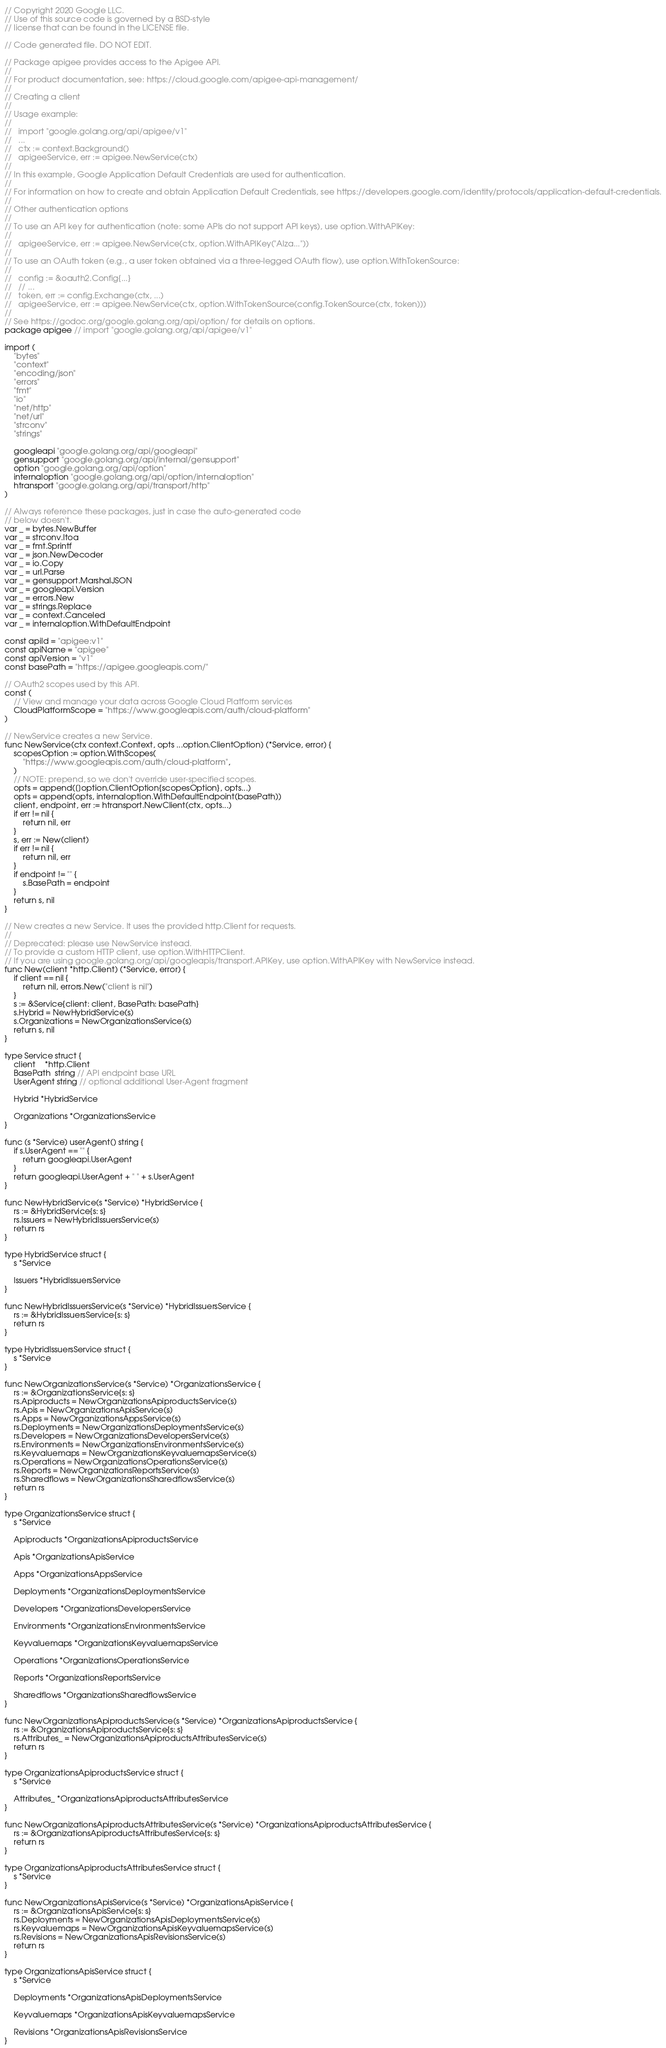<code> <loc_0><loc_0><loc_500><loc_500><_Go_>// Copyright 2020 Google LLC.
// Use of this source code is governed by a BSD-style
// license that can be found in the LICENSE file.

// Code generated file. DO NOT EDIT.

// Package apigee provides access to the Apigee API.
//
// For product documentation, see: https://cloud.google.com/apigee-api-management/
//
// Creating a client
//
// Usage example:
//
//   import "google.golang.org/api/apigee/v1"
//   ...
//   ctx := context.Background()
//   apigeeService, err := apigee.NewService(ctx)
//
// In this example, Google Application Default Credentials are used for authentication.
//
// For information on how to create and obtain Application Default Credentials, see https://developers.google.com/identity/protocols/application-default-credentials.
//
// Other authentication options
//
// To use an API key for authentication (note: some APIs do not support API keys), use option.WithAPIKey:
//
//   apigeeService, err := apigee.NewService(ctx, option.WithAPIKey("AIza..."))
//
// To use an OAuth token (e.g., a user token obtained via a three-legged OAuth flow), use option.WithTokenSource:
//
//   config := &oauth2.Config{...}
//   // ...
//   token, err := config.Exchange(ctx, ...)
//   apigeeService, err := apigee.NewService(ctx, option.WithTokenSource(config.TokenSource(ctx, token)))
//
// See https://godoc.org/google.golang.org/api/option/ for details on options.
package apigee // import "google.golang.org/api/apigee/v1"

import (
	"bytes"
	"context"
	"encoding/json"
	"errors"
	"fmt"
	"io"
	"net/http"
	"net/url"
	"strconv"
	"strings"

	googleapi "google.golang.org/api/googleapi"
	gensupport "google.golang.org/api/internal/gensupport"
	option "google.golang.org/api/option"
	internaloption "google.golang.org/api/option/internaloption"
	htransport "google.golang.org/api/transport/http"
)

// Always reference these packages, just in case the auto-generated code
// below doesn't.
var _ = bytes.NewBuffer
var _ = strconv.Itoa
var _ = fmt.Sprintf
var _ = json.NewDecoder
var _ = io.Copy
var _ = url.Parse
var _ = gensupport.MarshalJSON
var _ = googleapi.Version
var _ = errors.New
var _ = strings.Replace
var _ = context.Canceled
var _ = internaloption.WithDefaultEndpoint

const apiId = "apigee:v1"
const apiName = "apigee"
const apiVersion = "v1"
const basePath = "https://apigee.googleapis.com/"

// OAuth2 scopes used by this API.
const (
	// View and manage your data across Google Cloud Platform services
	CloudPlatformScope = "https://www.googleapis.com/auth/cloud-platform"
)

// NewService creates a new Service.
func NewService(ctx context.Context, opts ...option.ClientOption) (*Service, error) {
	scopesOption := option.WithScopes(
		"https://www.googleapis.com/auth/cloud-platform",
	)
	// NOTE: prepend, so we don't override user-specified scopes.
	opts = append([]option.ClientOption{scopesOption}, opts...)
	opts = append(opts, internaloption.WithDefaultEndpoint(basePath))
	client, endpoint, err := htransport.NewClient(ctx, opts...)
	if err != nil {
		return nil, err
	}
	s, err := New(client)
	if err != nil {
		return nil, err
	}
	if endpoint != "" {
		s.BasePath = endpoint
	}
	return s, nil
}

// New creates a new Service. It uses the provided http.Client for requests.
//
// Deprecated: please use NewService instead.
// To provide a custom HTTP client, use option.WithHTTPClient.
// If you are using google.golang.org/api/googleapis/transport.APIKey, use option.WithAPIKey with NewService instead.
func New(client *http.Client) (*Service, error) {
	if client == nil {
		return nil, errors.New("client is nil")
	}
	s := &Service{client: client, BasePath: basePath}
	s.Hybrid = NewHybridService(s)
	s.Organizations = NewOrganizationsService(s)
	return s, nil
}

type Service struct {
	client    *http.Client
	BasePath  string // API endpoint base URL
	UserAgent string // optional additional User-Agent fragment

	Hybrid *HybridService

	Organizations *OrganizationsService
}

func (s *Service) userAgent() string {
	if s.UserAgent == "" {
		return googleapi.UserAgent
	}
	return googleapi.UserAgent + " " + s.UserAgent
}

func NewHybridService(s *Service) *HybridService {
	rs := &HybridService{s: s}
	rs.Issuers = NewHybridIssuersService(s)
	return rs
}

type HybridService struct {
	s *Service

	Issuers *HybridIssuersService
}

func NewHybridIssuersService(s *Service) *HybridIssuersService {
	rs := &HybridIssuersService{s: s}
	return rs
}

type HybridIssuersService struct {
	s *Service
}

func NewOrganizationsService(s *Service) *OrganizationsService {
	rs := &OrganizationsService{s: s}
	rs.Apiproducts = NewOrganizationsApiproductsService(s)
	rs.Apis = NewOrganizationsApisService(s)
	rs.Apps = NewOrganizationsAppsService(s)
	rs.Deployments = NewOrganizationsDeploymentsService(s)
	rs.Developers = NewOrganizationsDevelopersService(s)
	rs.Environments = NewOrganizationsEnvironmentsService(s)
	rs.Keyvaluemaps = NewOrganizationsKeyvaluemapsService(s)
	rs.Operations = NewOrganizationsOperationsService(s)
	rs.Reports = NewOrganizationsReportsService(s)
	rs.Sharedflows = NewOrganizationsSharedflowsService(s)
	return rs
}

type OrganizationsService struct {
	s *Service

	Apiproducts *OrganizationsApiproductsService

	Apis *OrganizationsApisService

	Apps *OrganizationsAppsService

	Deployments *OrganizationsDeploymentsService

	Developers *OrganizationsDevelopersService

	Environments *OrganizationsEnvironmentsService

	Keyvaluemaps *OrganizationsKeyvaluemapsService

	Operations *OrganizationsOperationsService

	Reports *OrganizationsReportsService

	Sharedflows *OrganizationsSharedflowsService
}

func NewOrganizationsApiproductsService(s *Service) *OrganizationsApiproductsService {
	rs := &OrganizationsApiproductsService{s: s}
	rs.Attributes_ = NewOrganizationsApiproductsAttributesService(s)
	return rs
}

type OrganizationsApiproductsService struct {
	s *Service

	Attributes_ *OrganizationsApiproductsAttributesService
}

func NewOrganizationsApiproductsAttributesService(s *Service) *OrganizationsApiproductsAttributesService {
	rs := &OrganizationsApiproductsAttributesService{s: s}
	return rs
}

type OrganizationsApiproductsAttributesService struct {
	s *Service
}

func NewOrganizationsApisService(s *Service) *OrganizationsApisService {
	rs := &OrganizationsApisService{s: s}
	rs.Deployments = NewOrganizationsApisDeploymentsService(s)
	rs.Keyvaluemaps = NewOrganizationsApisKeyvaluemapsService(s)
	rs.Revisions = NewOrganizationsApisRevisionsService(s)
	return rs
}

type OrganizationsApisService struct {
	s *Service

	Deployments *OrganizationsApisDeploymentsService

	Keyvaluemaps *OrganizationsApisKeyvaluemapsService

	Revisions *OrganizationsApisRevisionsService
}
</code> 